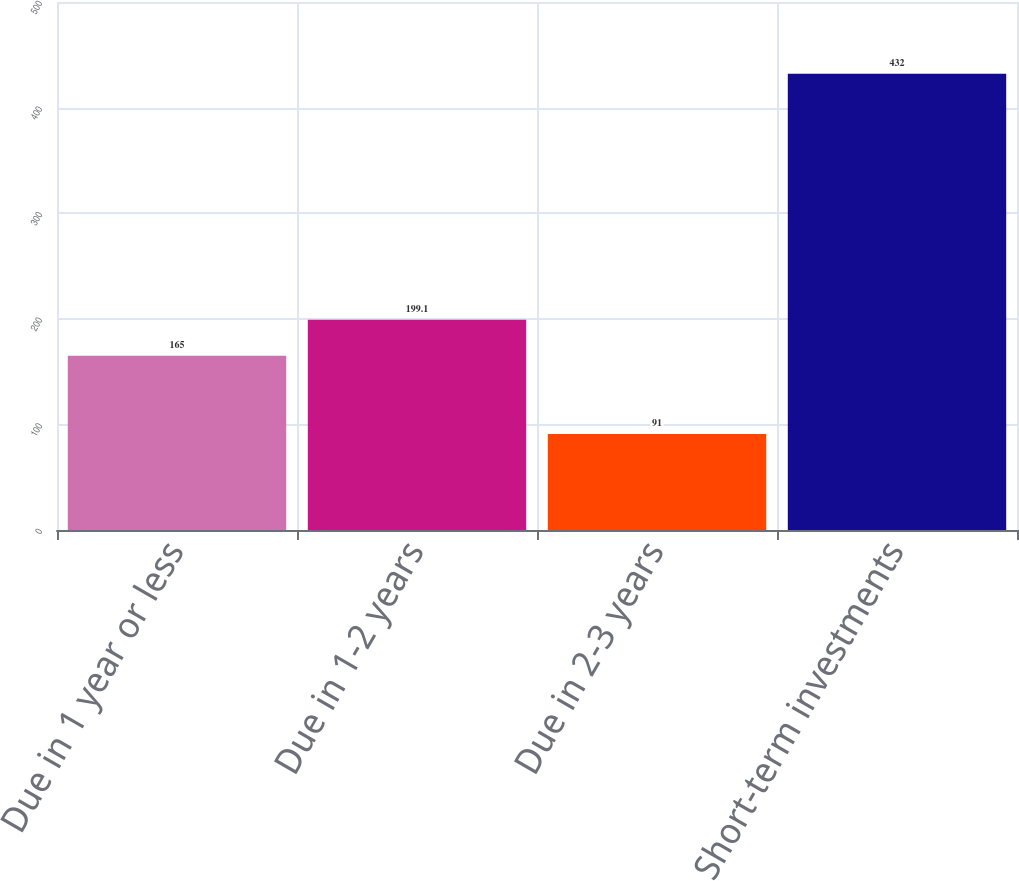Convert chart to OTSL. <chart><loc_0><loc_0><loc_500><loc_500><bar_chart><fcel>Due in 1 year or less<fcel>Due in 1-2 years<fcel>Due in 2-3 years<fcel>Short-term investments<nl><fcel>165<fcel>199.1<fcel>91<fcel>432<nl></chart> 